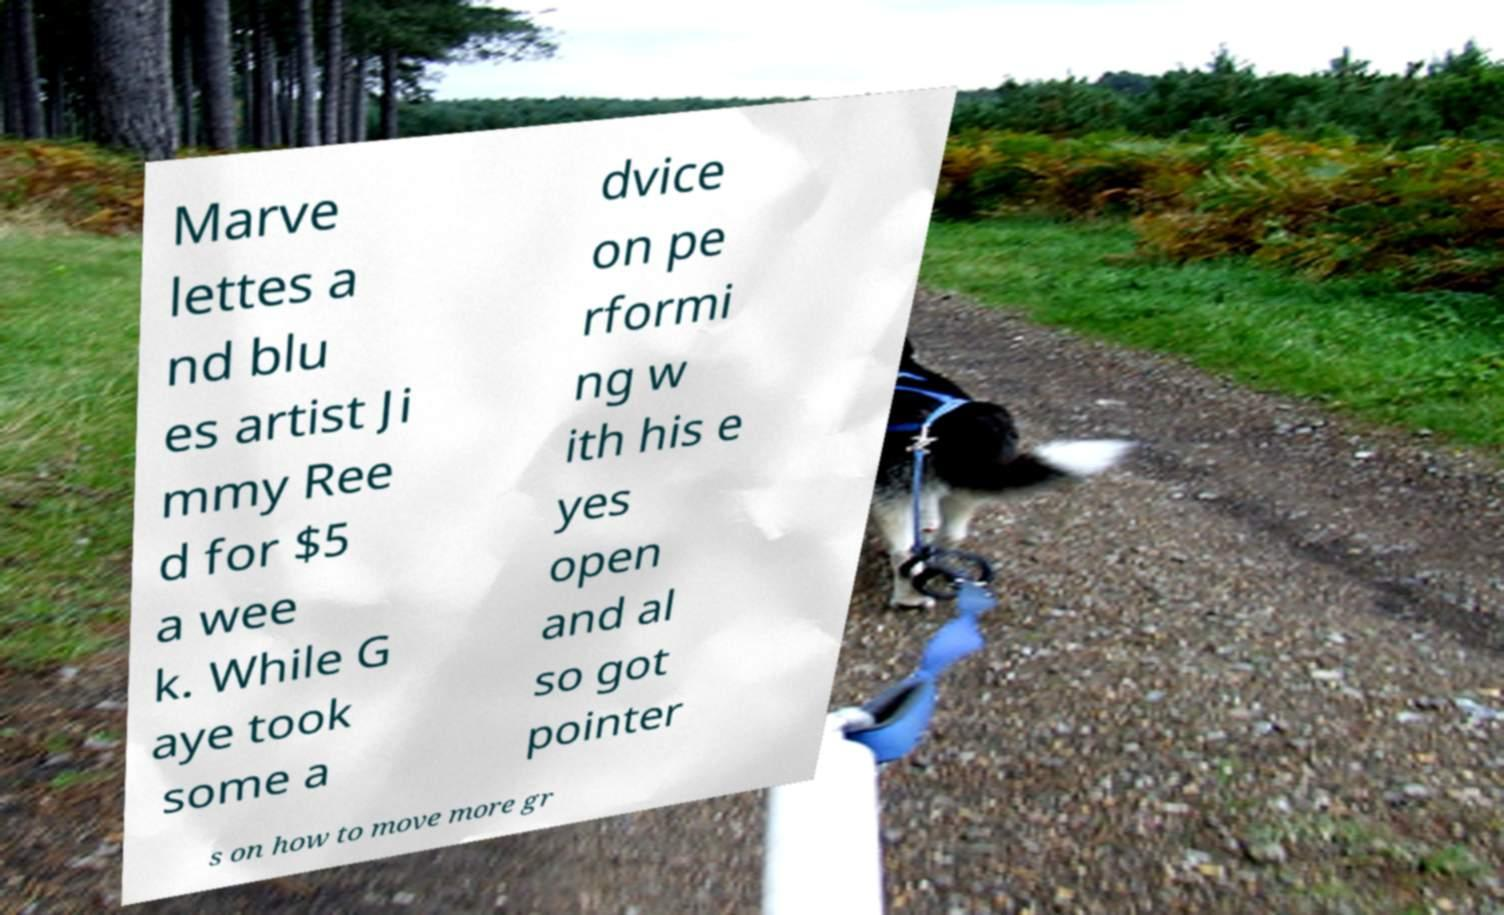For documentation purposes, I need the text within this image transcribed. Could you provide that? Marve lettes a nd blu es artist Ji mmy Ree d for $5 a wee k. While G aye took some a dvice on pe rformi ng w ith his e yes open and al so got pointer s on how to move more gr 